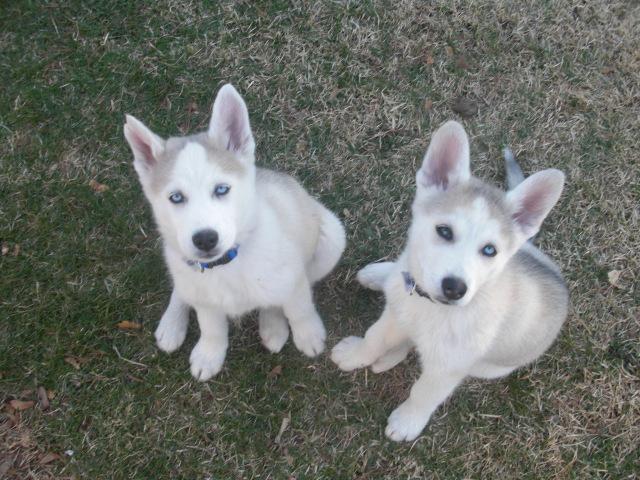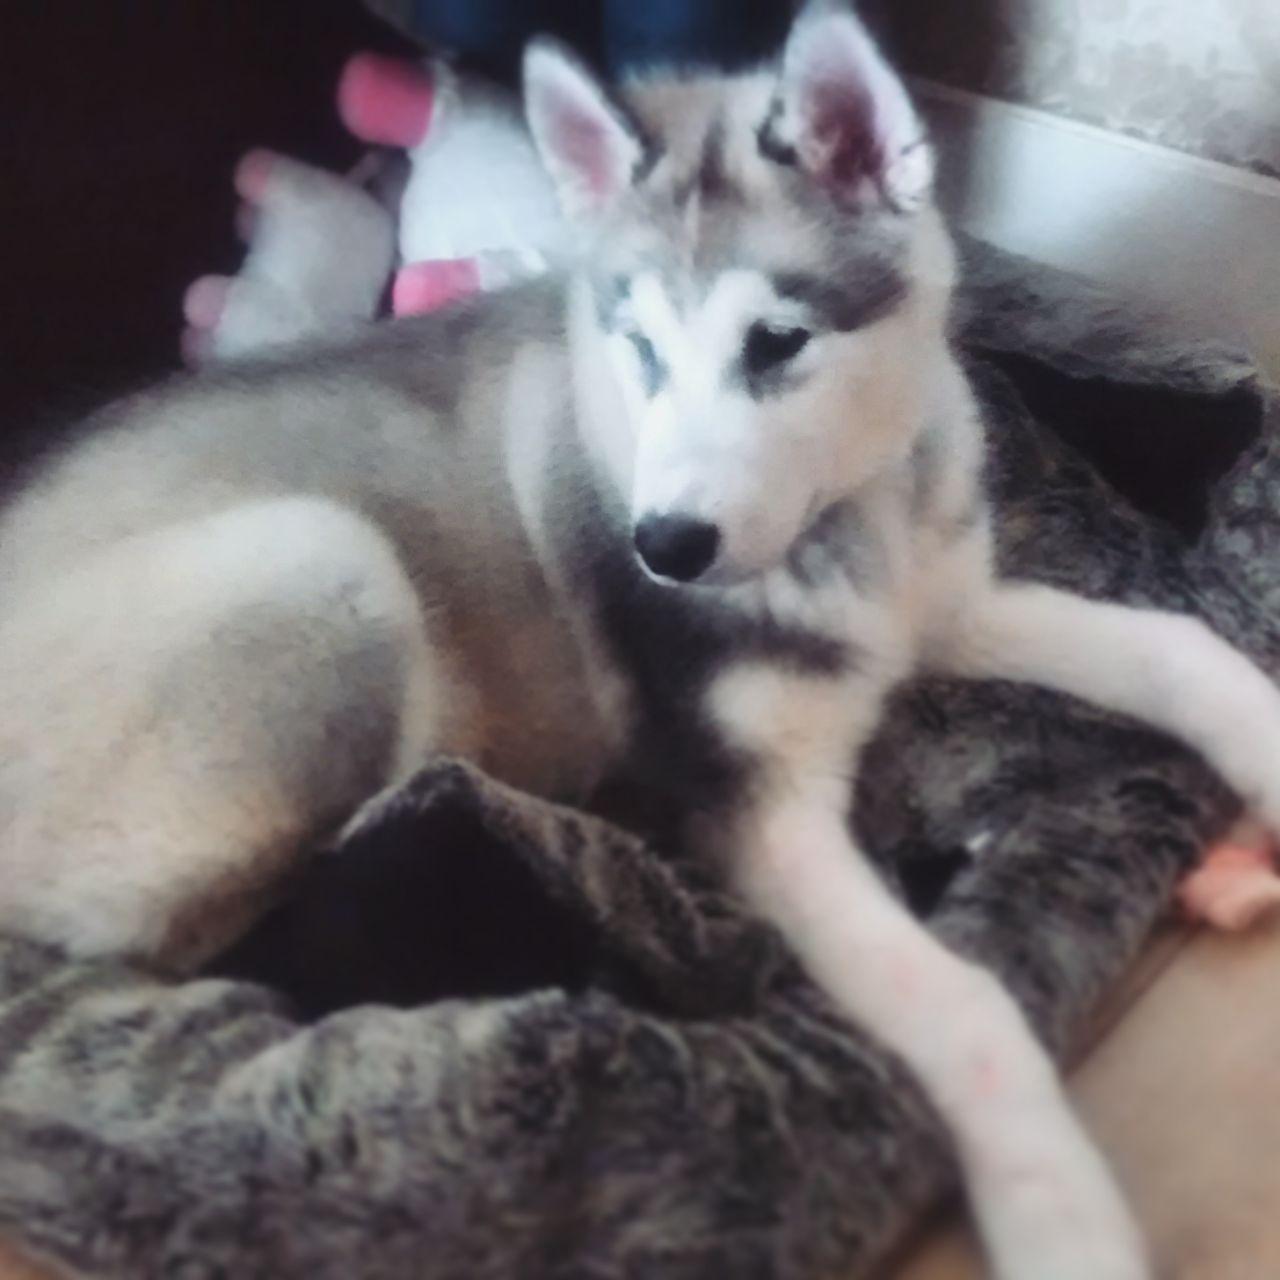The first image is the image on the left, the second image is the image on the right. For the images displayed, is the sentence "There are three dogs" factually correct? Answer yes or no. Yes. The first image is the image on the left, the second image is the image on the right. Considering the images on both sides, is "All dogs are young husky puppies, the combined images include at least two black-and-white puppies, and one image shows a pair of puppies with all floppy ears, posed side-by-side and facing the camera." valid? Answer yes or no. No. 